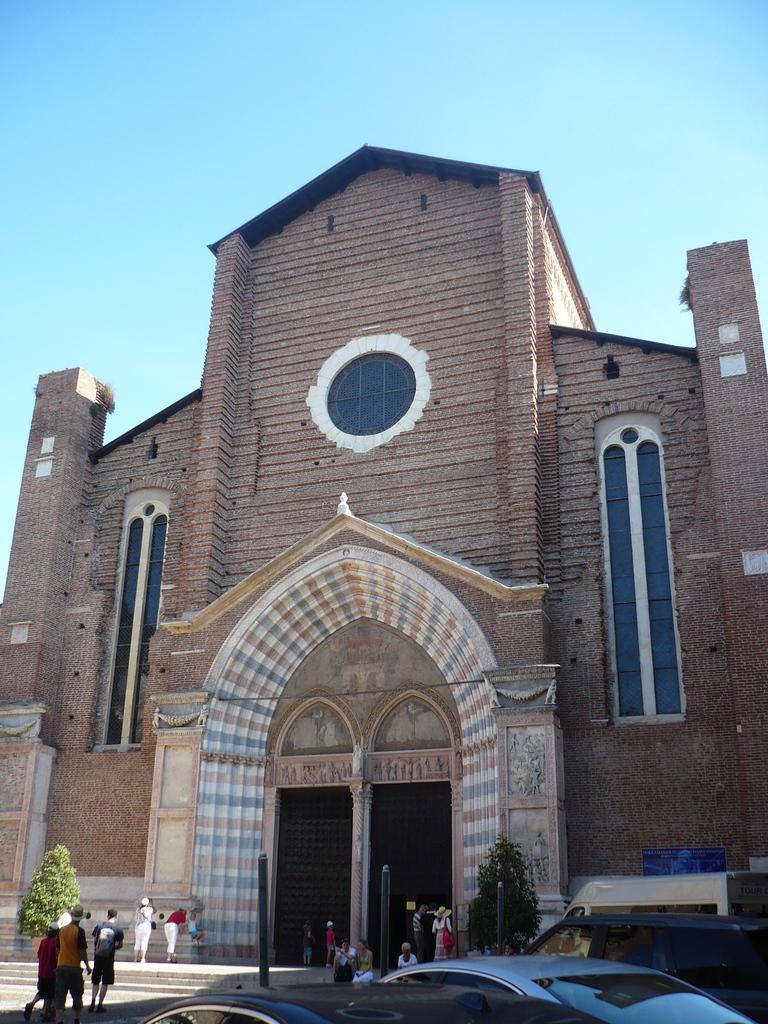In one or two sentences, can you explain what this image depicts? This is an outside view. At the bottom there are few cars and few people walking on the ground. In the middle of the image there is a building. In front of the building there are two trees. At the top of the image I can see the sky. 